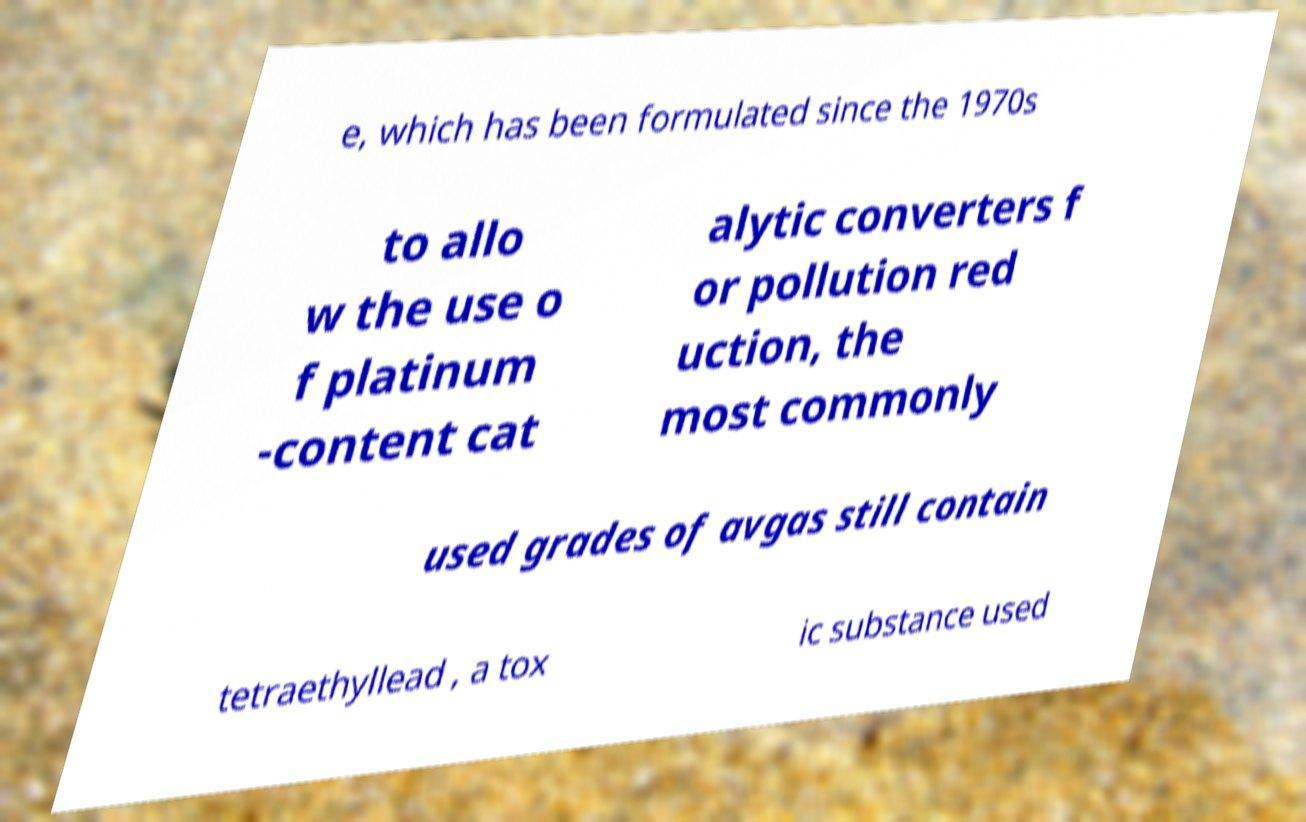What messages or text are displayed in this image? I need them in a readable, typed format. e, which has been formulated since the 1970s to allo w the use o f platinum -content cat alytic converters f or pollution red uction, the most commonly used grades of avgas still contain tetraethyllead , a tox ic substance used 